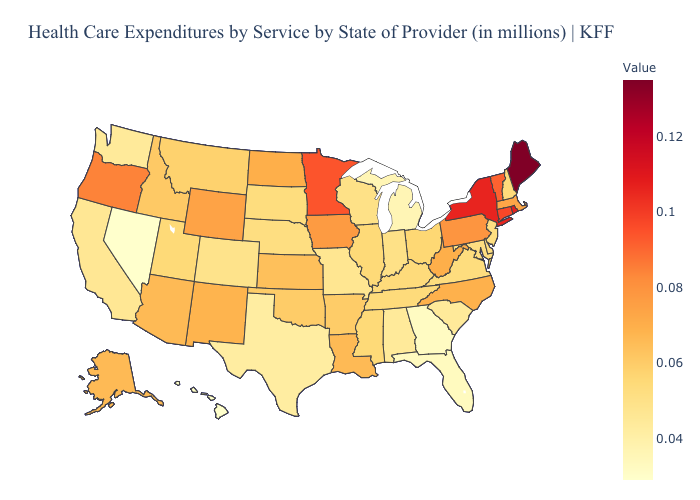Which states hav the highest value in the South?
Write a very short answer. West Virginia. Is the legend a continuous bar?
Give a very brief answer. Yes. Which states have the lowest value in the MidWest?
Be succinct. Michigan. Does Colorado have the highest value in the USA?
Answer briefly. No. Does the map have missing data?
Short answer required. No. Does Louisiana have a lower value than Indiana?
Quick response, please. No. Which states have the lowest value in the MidWest?
Concise answer only. Michigan. Does Utah have a lower value than Nevada?
Give a very brief answer. No. Which states have the lowest value in the USA?
Keep it brief. Hawaii, Nevada. 